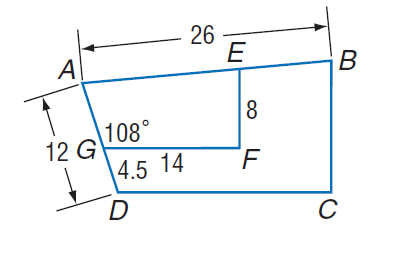Answer the mathemtical geometry problem and directly provide the correct option letter.
Question: Polygon A B C D \sim polygon A E F G, m \angle A G F = 108, G F = 14, A D = 12, D G = 4.5, E F = 8, and A B = 26. Find A G.
Choices: A: 4.5 B: 7.5 C: 12 D: 20 B 